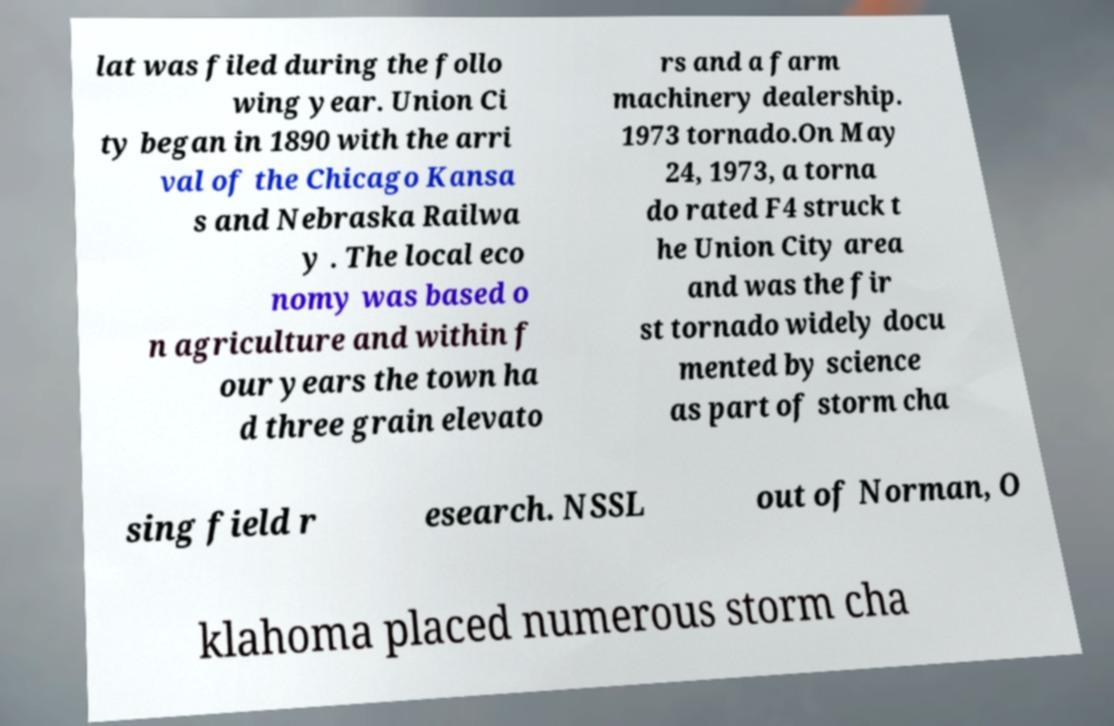For documentation purposes, I need the text within this image transcribed. Could you provide that? lat was filed during the follo wing year. Union Ci ty began in 1890 with the arri val of the Chicago Kansa s and Nebraska Railwa y . The local eco nomy was based o n agriculture and within f our years the town ha d three grain elevato rs and a farm machinery dealership. 1973 tornado.On May 24, 1973, a torna do rated F4 struck t he Union City area and was the fir st tornado widely docu mented by science as part of storm cha sing field r esearch. NSSL out of Norman, O klahoma placed numerous storm cha 